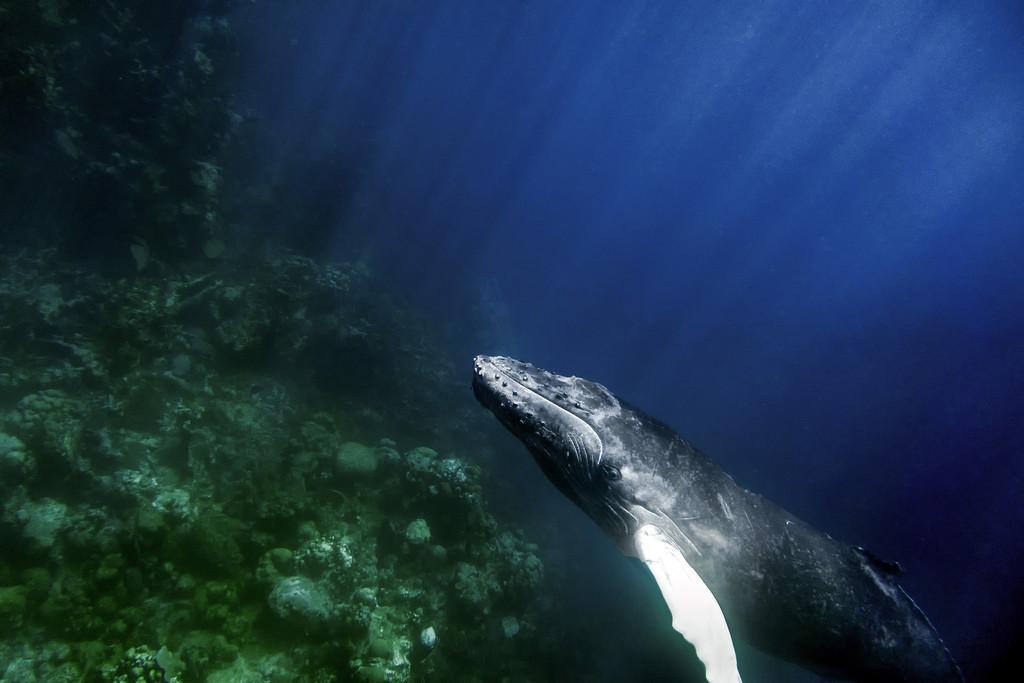How would you summarize this image in a sentence or two? It is an underground water environment. In this image, we can see fish and corals. 